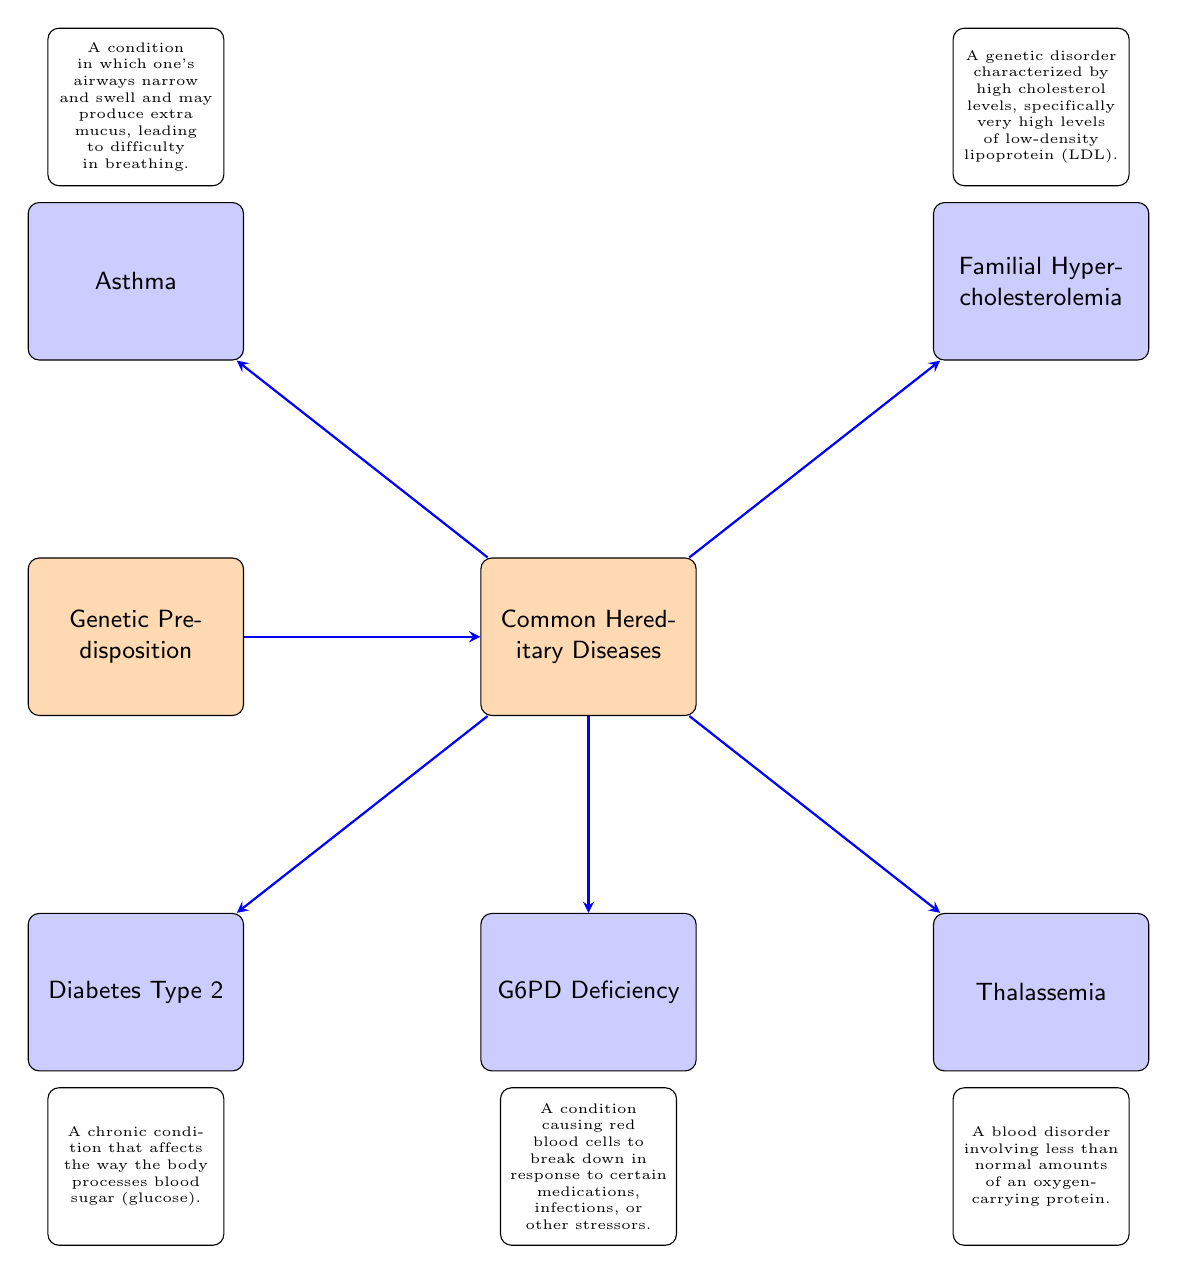What is the main node labeled as? The diagram shows a main node that is labeled "Genetic Predisposition," which indicates the overarching concept linking to hereditary diseases.
Answer: Genetic Predisposition How many common hereditary diseases are displayed in the diagram? The diagram features five common hereditary diseases, as evidenced by the five disease nodes branching from the common hereditary diseases node.
Answer: 5 Which disease is linked to "G6PD Deficiency"? "G6PD Deficiency" is a disease directly connected to the "Common Hereditary Diseases" node, indicating it falls under the category of diseases that have a hereditary basis.
Answer: G6PD Deficiency What type of condition is "Thalassemia"? Thalassemia is defined in the diagram as a blood disorder that involves less than normal amounts of an oxygen-carrying protein, categorizing it specifically within hereditary diseases.
Answer: A blood disorder Which diseases are associated with high cholesterol levels according to the diagram? The diagram states that familial hypercholesterolemia is the condition associated with high cholesterol levels, as indicated in its description.
Answer: Familial Hypercholesterolemia If "Genetic Predisposition" is present, how many corresponding diseases can follow? From the "Genetic Predisposition" node, there are five arrows leading to hereditary diseases, which indicates the number of diseases that can follow.
Answer: 5 What two diseases are located below the "Common Hereditary Diseases" node? At the bottom of the diagram, "G6PD Deficiency" and "Diabetes Type 2" are positioned below "Common Hereditary Diseases," indicating their direct association with hereditary implications.
Answer: G6PD Deficiency and Diabetes Type 2 Which disease description mentions airway narrowing? The disease description that mentions airway narrowing and swelling is for "Asthma," as described in the context of difficulty in breathing.
Answer: Asthma What is the relationship between "Genetic Predisposition" and "Common Hereditary Diseases"? "Genetic Predisposition" serves as a prerequisite that leads to the understanding of "Common Hereditary Diseases," highlighting its role as a foundational concept in the diagram.
Answer: Direct influence 